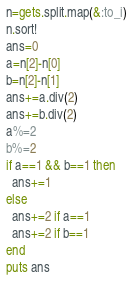<code> <loc_0><loc_0><loc_500><loc_500><_Ruby_>n=gets.split.map(&:to_i)
n.sort!
ans=0
a=n[2]-n[0]
b=n[2]-n[1]
ans+=a.div(2)
ans+=b.div(2)
a%=2
b%=2
if a==1 && b==1 then
  ans+=1
else
  ans+=2 if a==1
  ans+=2 if b==1
end
puts ans</code> 